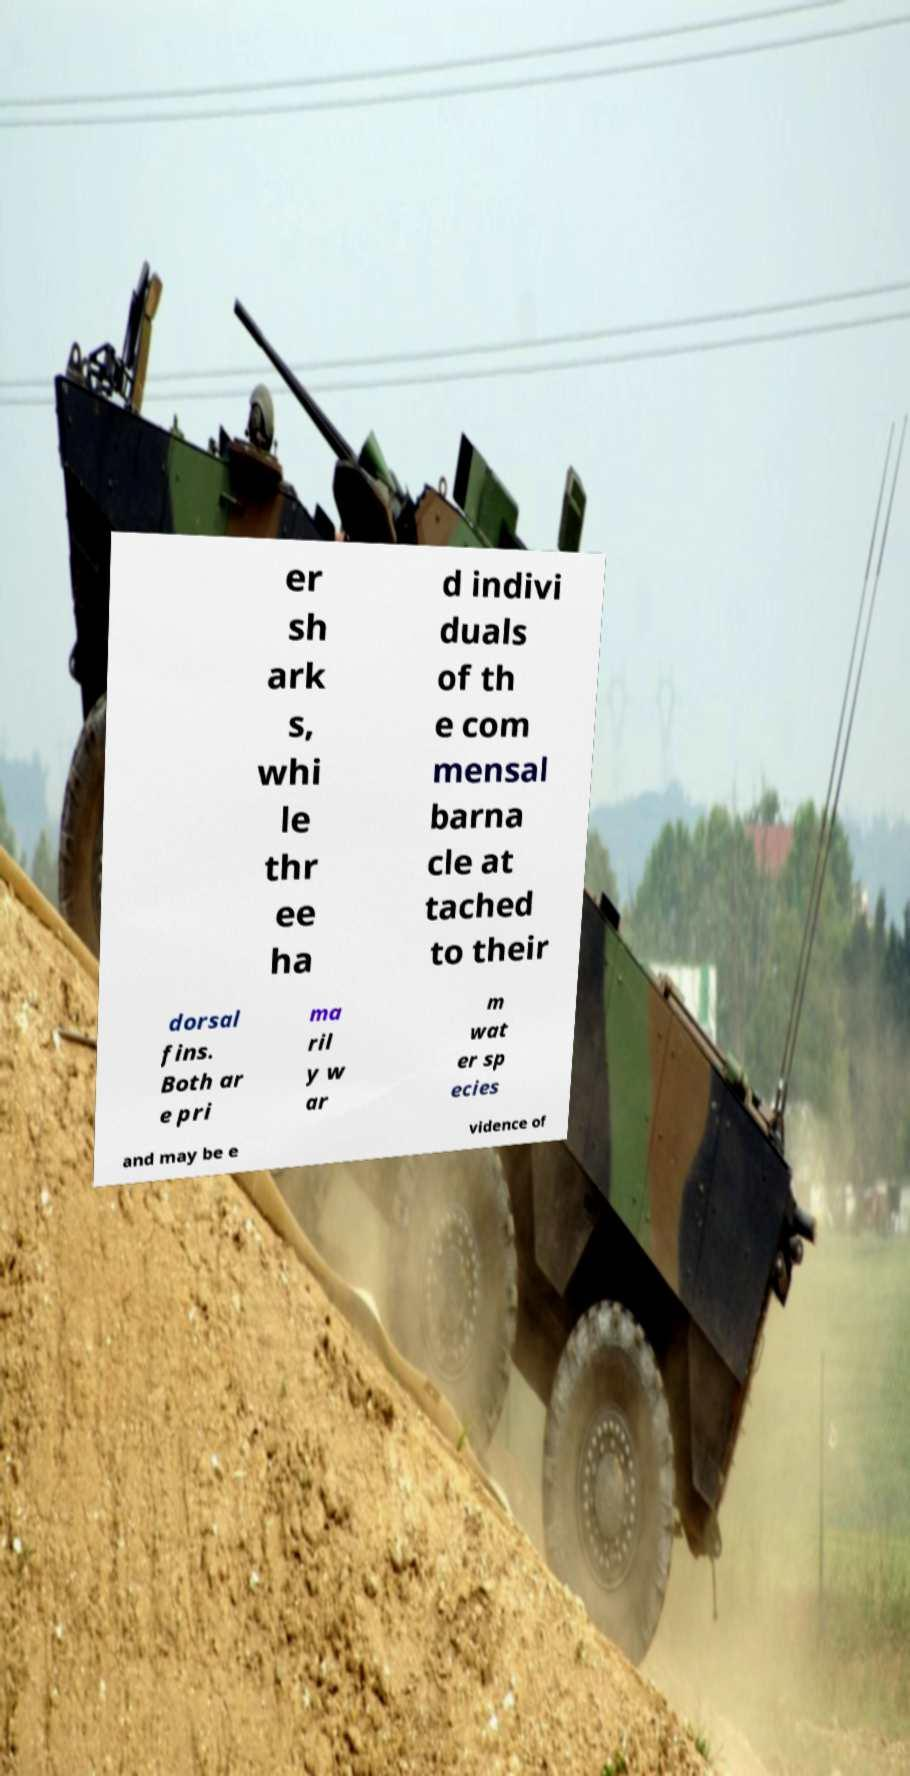Could you assist in decoding the text presented in this image and type it out clearly? er sh ark s, whi le thr ee ha d indivi duals of th e com mensal barna cle at tached to their dorsal fins. Both ar e pri ma ril y w ar m wat er sp ecies and may be e vidence of 